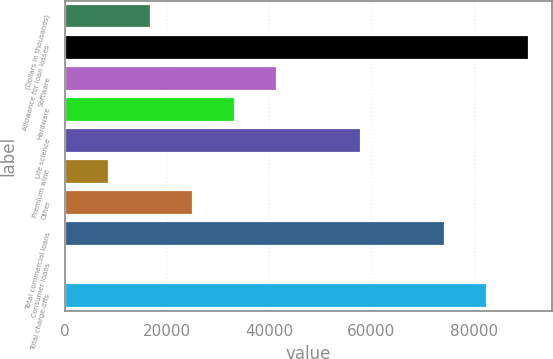Convert chart. <chart><loc_0><loc_0><loc_500><loc_500><bar_chart><fcel>(Dollars in thousands)<fcel>Allowance for loan losses<fcel>Software<fcel>Hardware<fcel>Life science<fcel>Premium wine<fcel>Other<fcel>Total commercial loans<fcel>Consumer loans<fcel>Total charge-offs<nl><fcel>16916.6<fcel>90840.8<fcel>41558<fcel>33344.2<fcel>57985.6<fcel>8702.8<fcel>25130.4<fcel>74413.2<fcel>489<fcel>82627<nl></chart> 